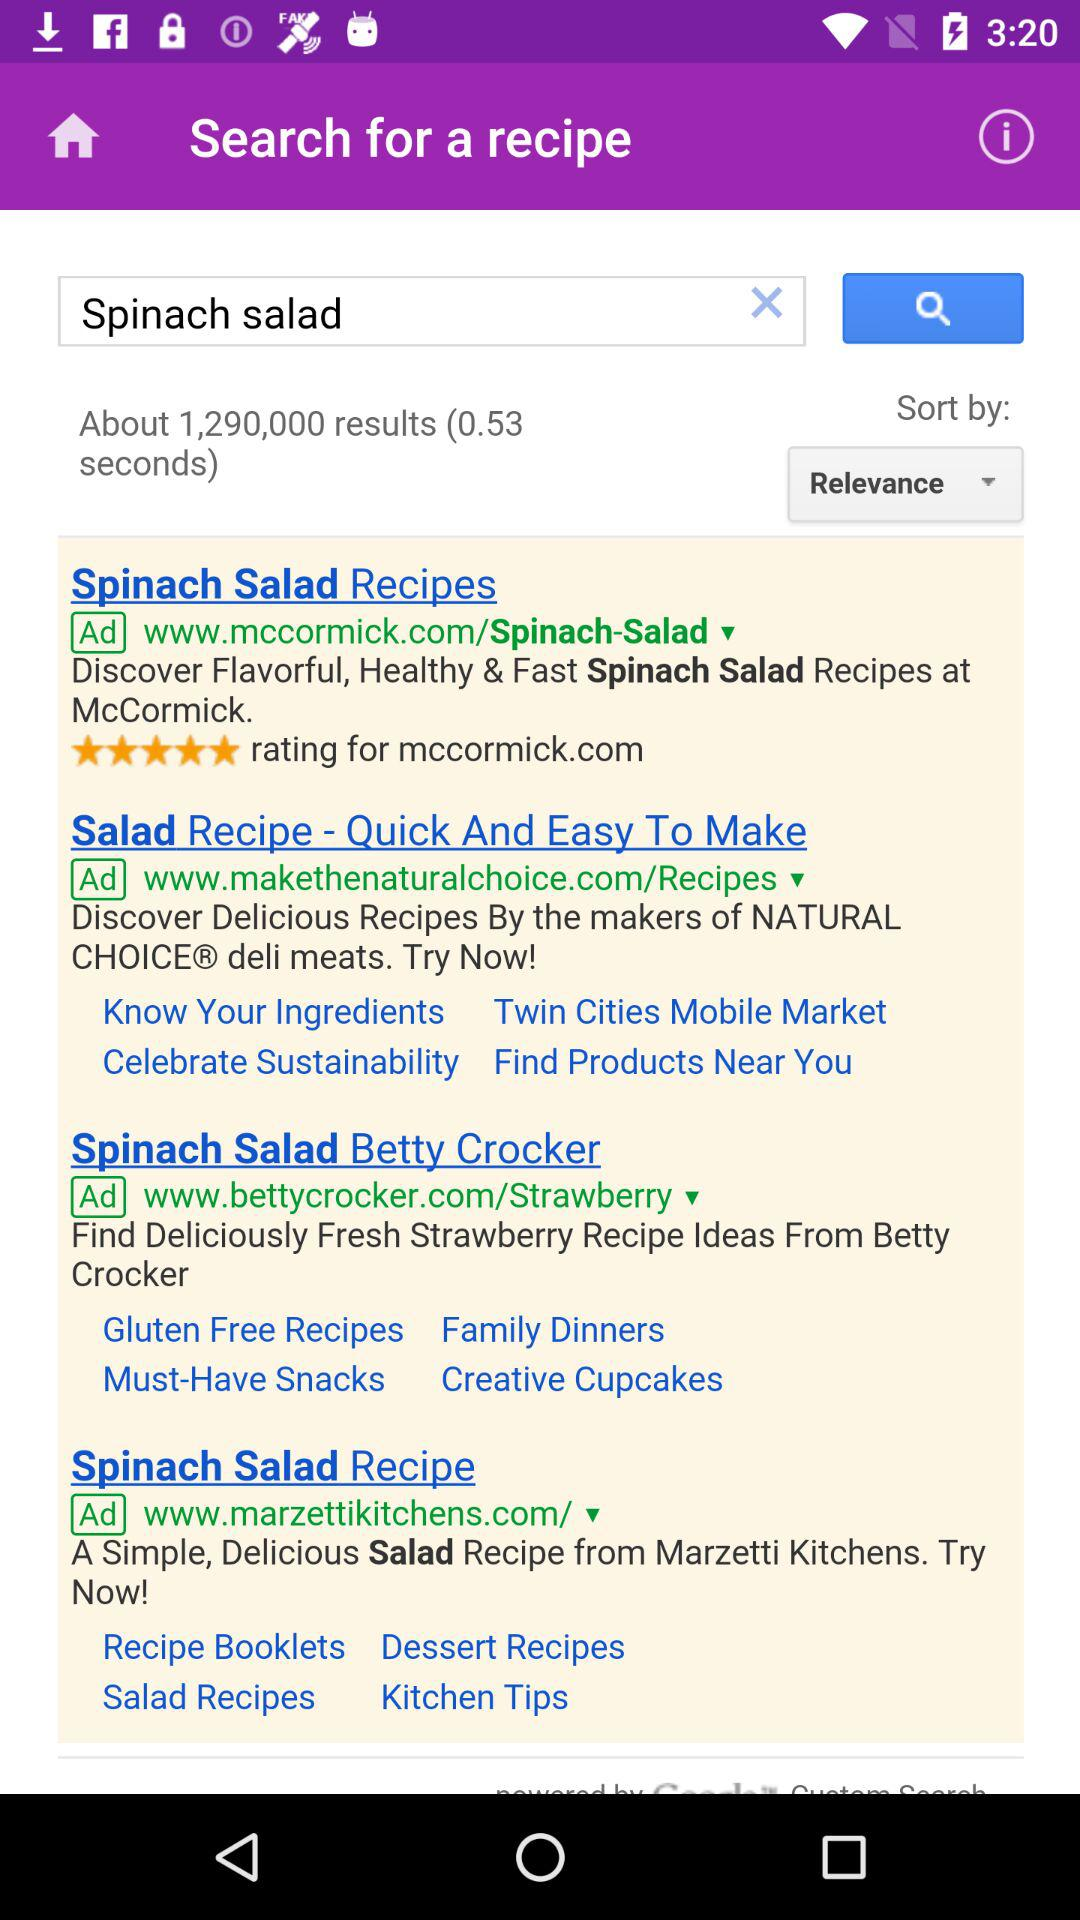How were the results sorted? The results were sorted by relevance. 